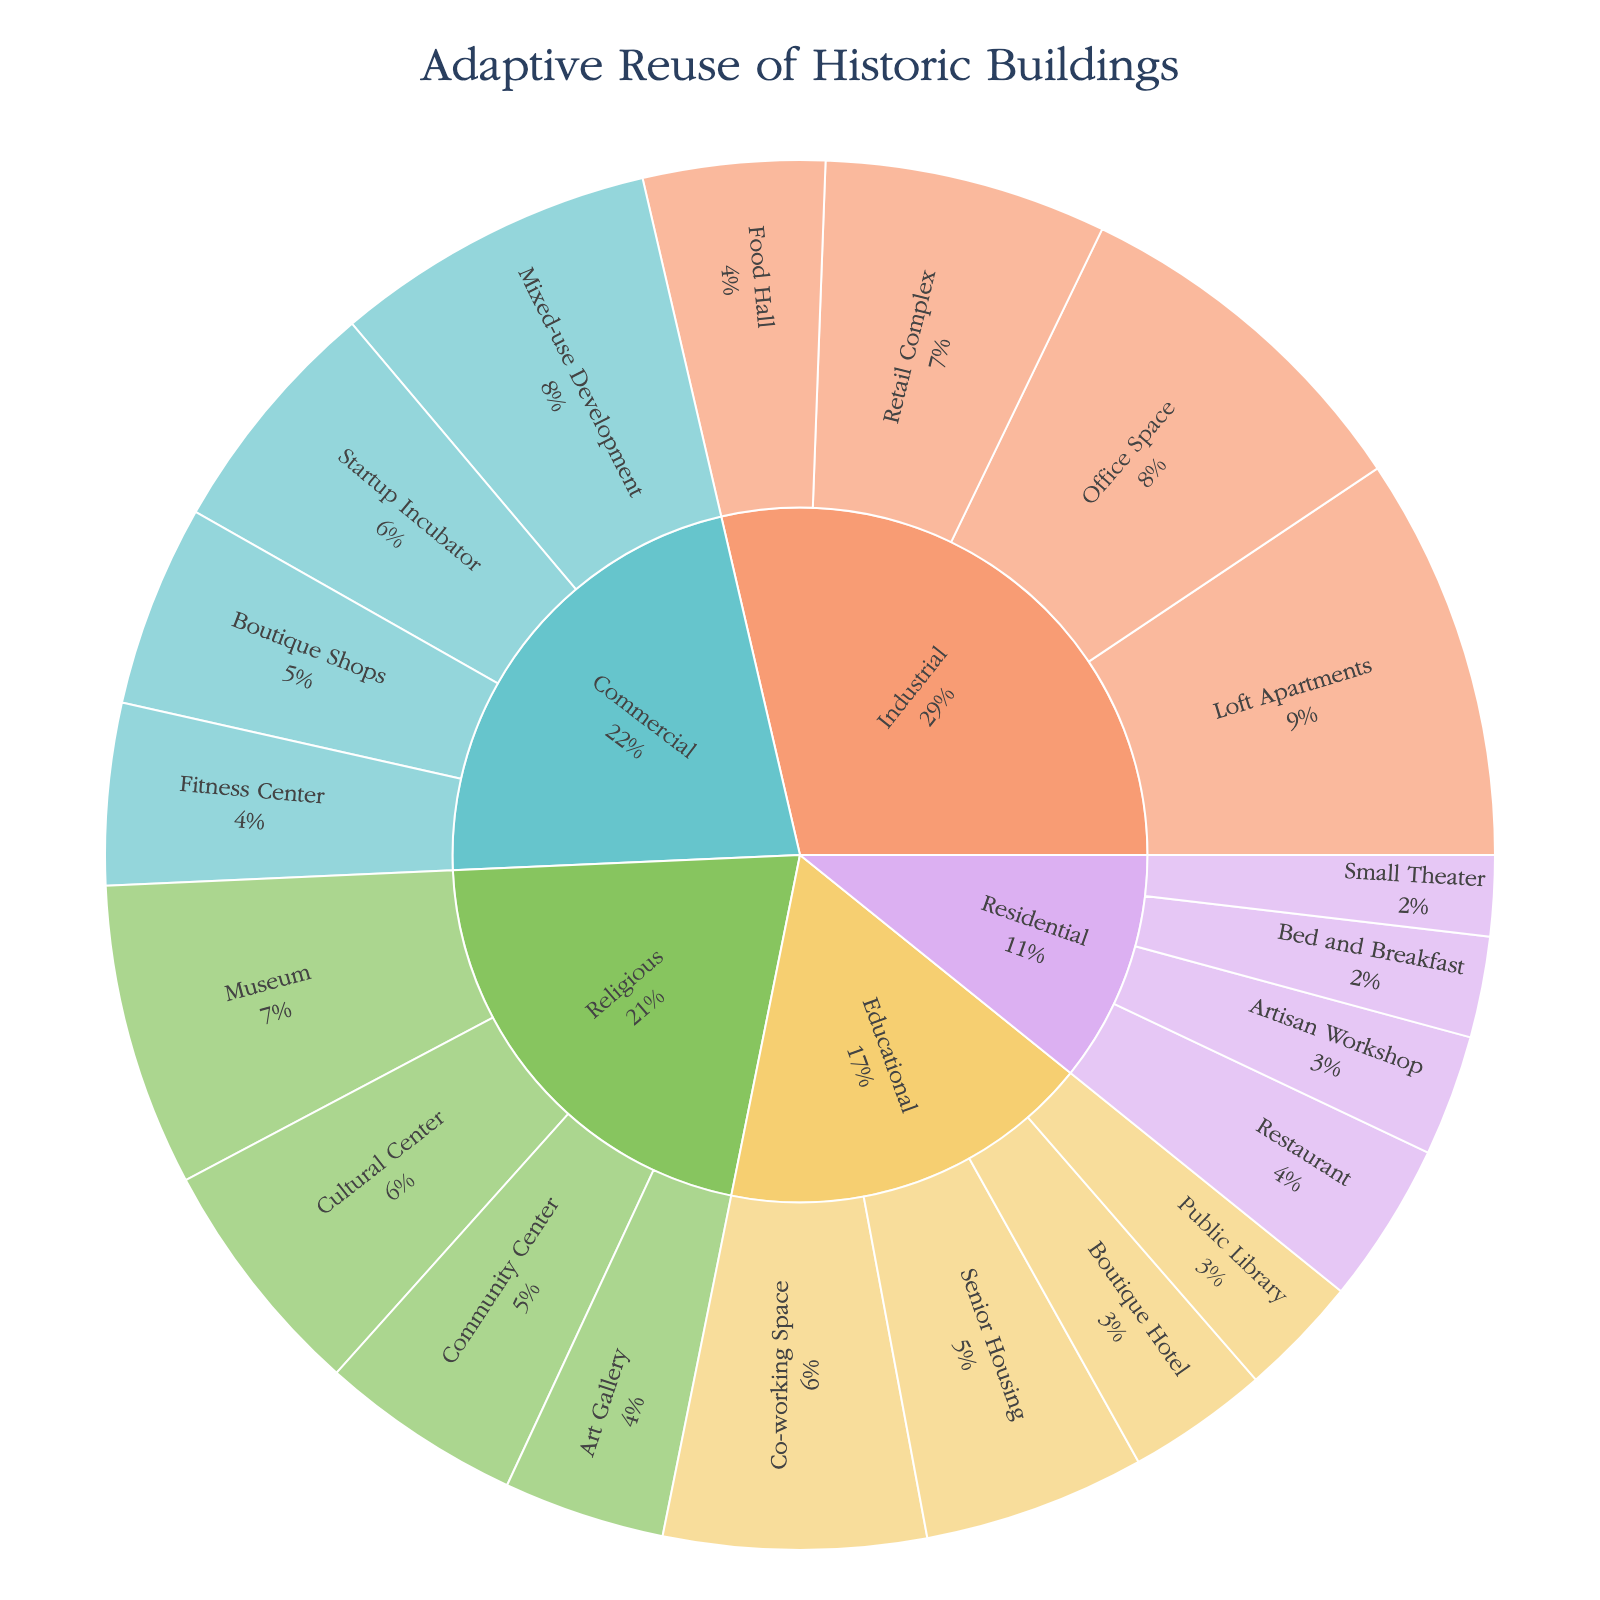How many adaptive reuse projects originally served religious purposes? Look at the outer ring of the sunburst plot, find the segments under the "Religious" category and add up the counts of each new function: Cultural Center (12), Museum (15), Art Gallery (8), Community Center (10). The sum is 12 + 15 + 8 + 10.
Answer: 45 Which original purpose category has the highest number of adaptive reuse projects? Compare the total counts of projects for each original purpose by summing their respective segments in the outer ring. For "Religious," it's 45. For "Industrial," it is 61 (20+18+14+9). For "Educational," it is 37 (7+11+13+6). For "Residential," it is 23 (5+8+6+4). For "Commercial," it is 47 (16+9+12+10). Therefore, the "Industrial" category has the highest total count.
Answer: Industrial What's the ratio of adaptive reuse projects converting religious buildings into cultural centers compared to those converting industrial buildings into office spaces? Find the counts for "Religious to Cultural Center" (12) and "Industrial to Office Space" (18). The ratio is 12:18, which simplifies to 2:3.
Answer: 2:3 How many more adaptive reuse projects convert industrial buildings into loft apartments compared to those converting educational buildings into co-working spaces? Identify the counts: Industrial to Loft Apartments (20), Educational to Co-working Space (13). Subtract to find the difference: 20 - 13.
Answer: 7 Which new function has the highest count of adaptive reuse projects for historic buildings originally used for educational purposes? Look at the segments under "Educational" and compare the counts: Boutique Hotel (7), Senior Housing (11), Co-working Space (13), Public Library (6). The largest count is for Co-working Space.
Answer: Co-working Space How many adaptive reuse projects result in food halls, regardless of the original purpose? Identify the count for "Industrial to Food Hall" (9) as it is the only project converting to a food hall.
Answer: 9 Which original purpose has the least number of projects repurposed into a single new function, and what is that function? Go through the outer ring and find the lowest single new function count under each original purpose: Residential to Small Theater (4) is the smallest at 4, compared to others.
Answer: Residential to Small Theater If you combined the new functions of boutique shops and retail complex, how many projects involve converting commercial and industrial buildings to these new uses? Sum the counts for "Commercial to Boutique Shops" (10) and "Industrial to Retail Complex" (14). The total is 10 + 14.
Answer: 24 